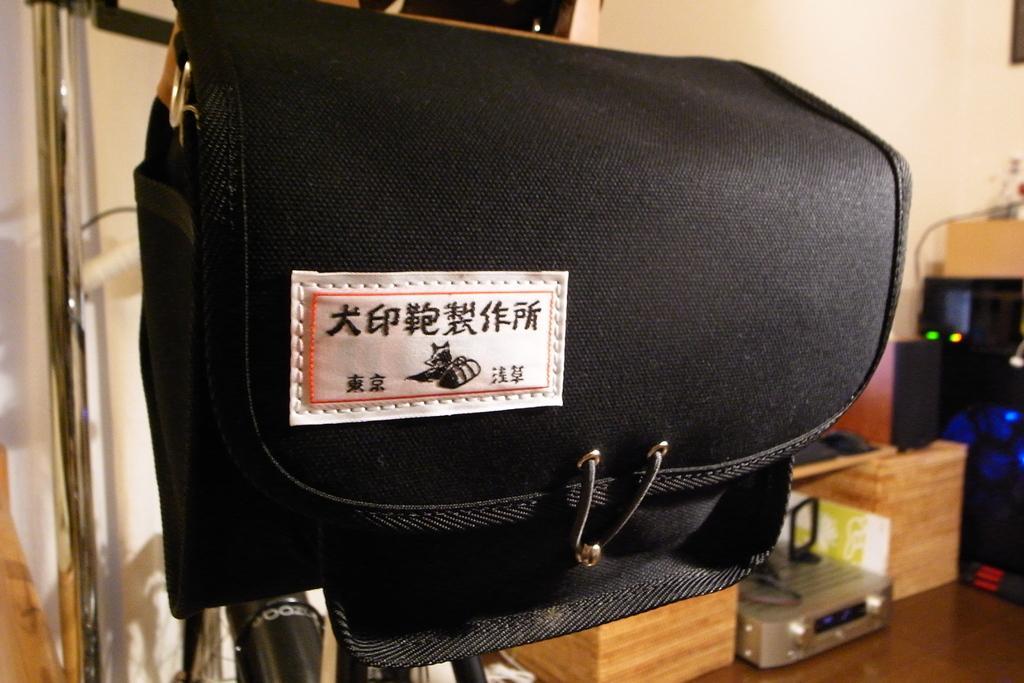Describe this image in one or two sentences. The image is taken inside a room. In the foreground of the picture there is a bag. The background is blurred. On the left there is a door. On the right there are boxes and some electronic gadgets. At the top it is wall painted white. 